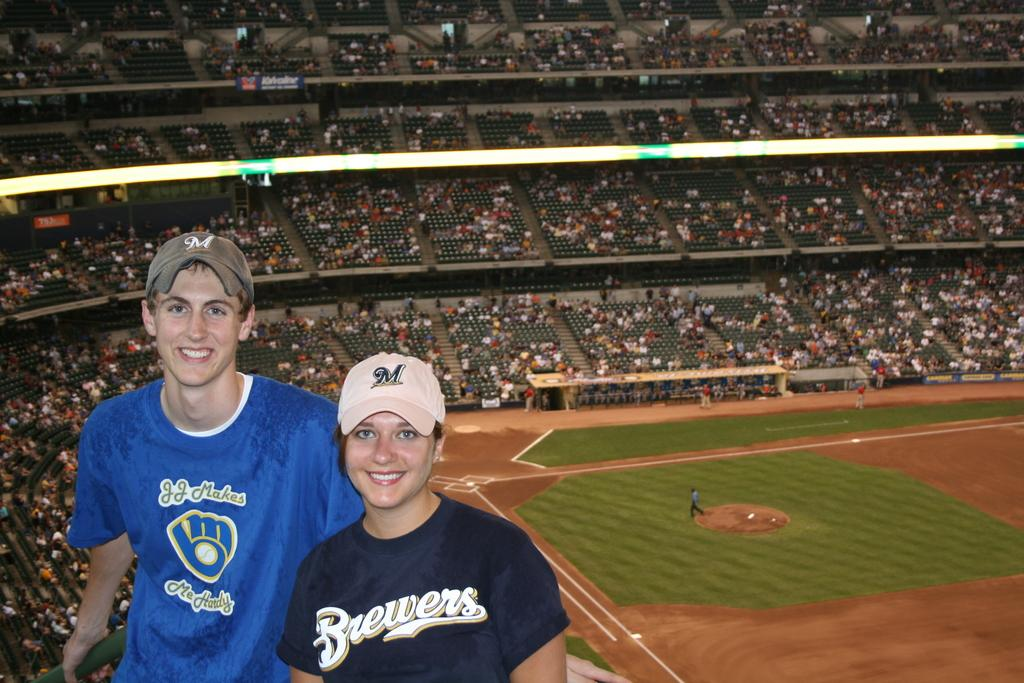<image>
Summarize the visual content of the image. A man and a woman in a Brewers shirt pose for a picture in a stadium. 